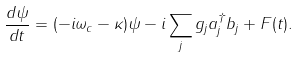Convert formula to latex. <formula><loc_0><loc_0><loc_500><loc_500>\frac { d \psi } { d t } = ( - i \omega _ { c } - \kappa ) \psi - i \sum _ { j } g _ { j } a ^ { \dagger } _ { j } b _ { j } + F ( t ) .</formula> 